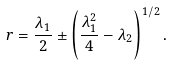<formula> <loc_0><loc_0><loc_500><loc_500>r = \frac { \lambda _ { 1 } } { 2 } \pm \left ( \frac { \lambda _ { 1 } ^ { 2 } } { 4 } - \lambda _ { 2 } \right ) ^ { 1 / 2 } .</formula> 